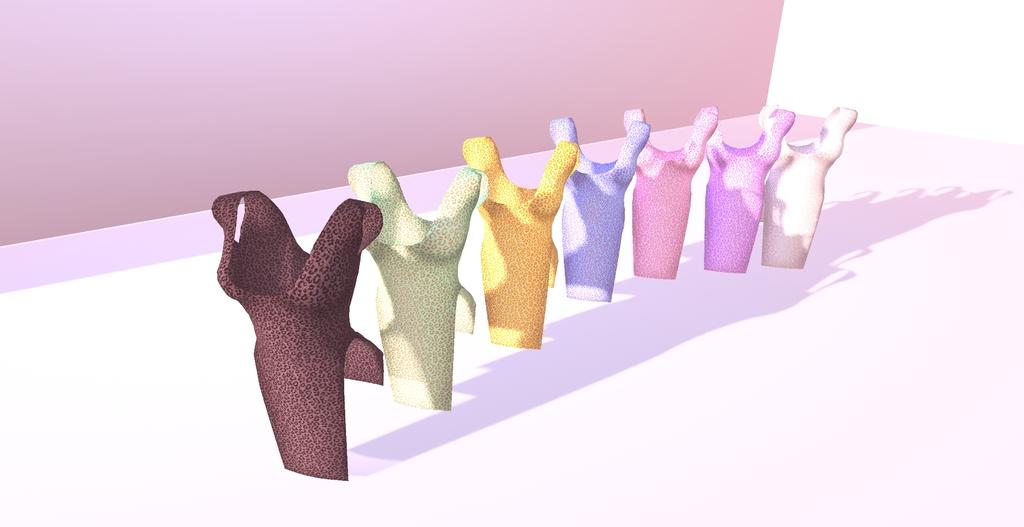What objects are featured in the image? There are animated tops in the image. What color is the wall in the background of the image? The wall in the background of the image is pink. What type of addition problem can be solved using the animated tops in the image? There is no addition problem present in the image, as it features animated tops and a pink wall. Is there a bedroom visible in the image? There is no bedroom visible in the image; it only shows animated tops and a pink wall. 